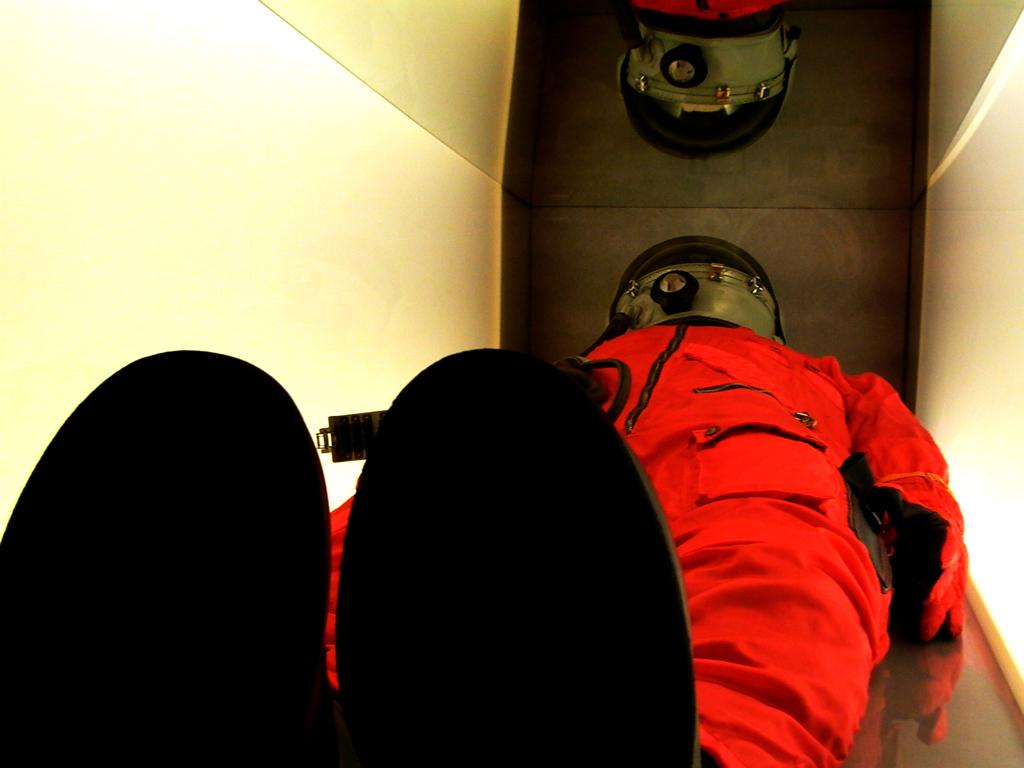What is present in the room according to the image? There is a person in the room. Can you describe the person's attire? The person is wearing a red color suit. What degree does the person in the room hold? There is no information about the person's degree in the image. What type of jeans is the person wearing in the image? The person is not wearing jeans in the image; they are wearing a red color suit. 